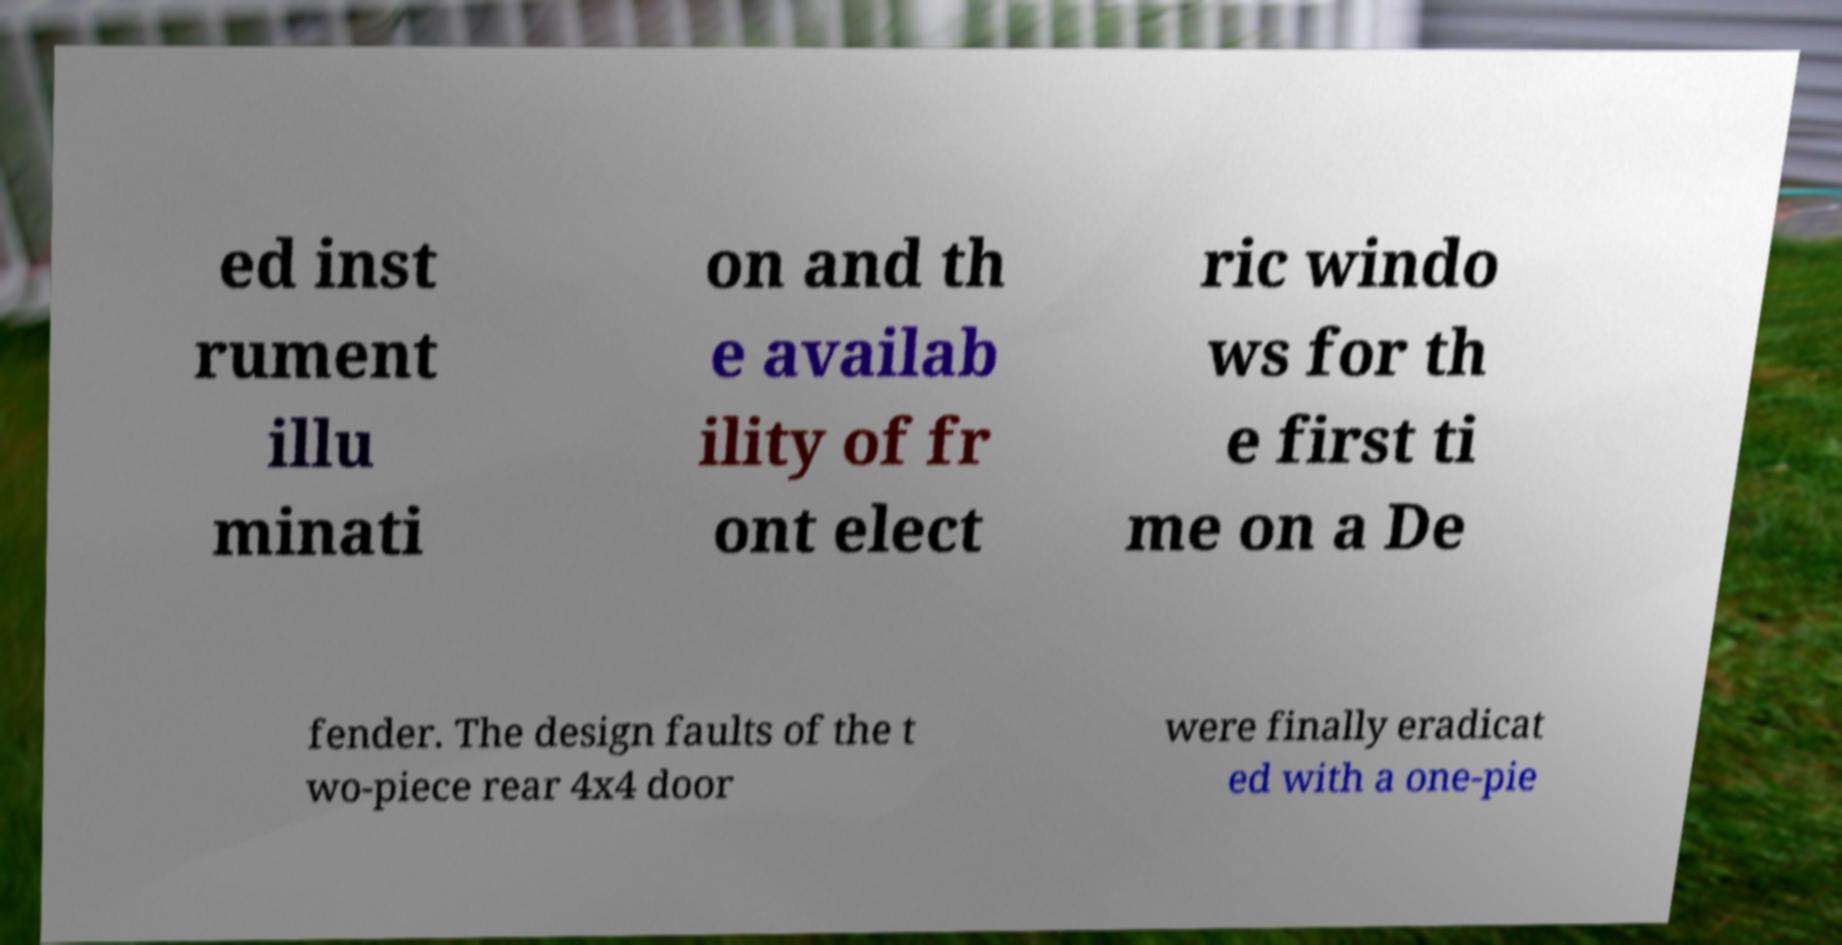For documentation purposes, I need the text within this image transcribed. Could you provide that? ed inst rument illu minati on and th e availab ility of fr ont elect ric windo ws for th e first ti me on a De fender. The design faults of the t wo-piece rear 4x4 door were finally eradicat ed with a one-pie 